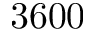Convert formula to latex. <formula><loc_0><loc_0><loc_500><loc_500>3 6 0 0</formula> 